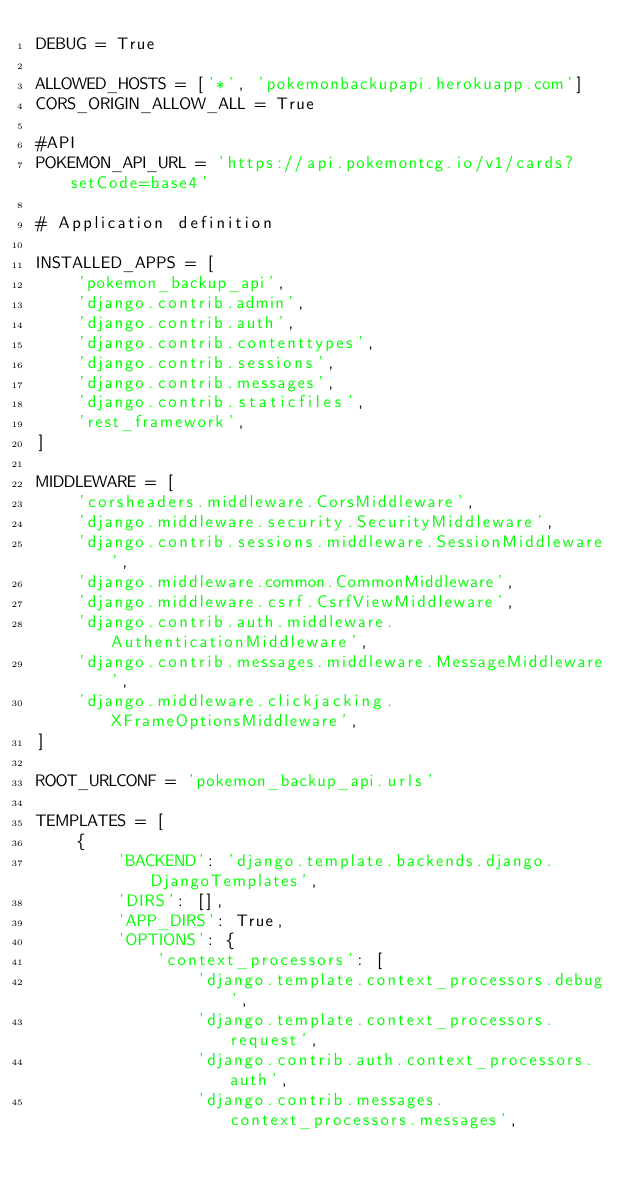Convert code to text. <code><loc_0><loc_0><loc_500><loc_500><_Python_>DEBUG = True

ALLOWED_HOSTS = ['*', 'pokemonbackupapi.herokuapp.com']
CORS_ORIGIN_ALLOW_ALL = True

#API
POKEMON_API_URL = 'https://api.pokemontcg.io/v1/cards?setCode=base4'

# Application definition

INSTALLED_APPS = [
    'pokemon_backup_api',
    'django.contrib.admin',
    'django.contrib.auth',
    'django.contrib.contenttypes',
    'django.contrib.sessions',
    'django.contrib.messages',
    'django.contrib.staticfiles',
    'rest_framework',
]

MIDDLEWARE = [
    'corsheaders.middleware.CorsMiddleware',
    'django.middleware.security.SecurityMiddleware',
    'django.contrib.sessions.middleware.SessionMiddleware',
    'django.middleware.common.CommonMiddleware',
    'django.middleware.csrf.CsrfViewMiddleware',
    'django.contrib.auth.middleware.AuthenticationMiddleware',
    'django.contrib.messages.middleware.MessageMiddleware',
    'django.middleware.clickjacking.XFrameOptionsMiddleware',
]

ROOT_URLCONF = 'pokemon_backup_api.urls'

TEMPLATES = [
    {
        'BACKEND': 'django.template.backends.django.DjangoTemplates',
        'DIRS': [],
        'APP_DIRS': True,
        'OPTIONS': {
            'context_processors': [
                'django.template.context_processors.debug',
                'django.template.context_processors.request',
                'django.contrib.auth.context_processors.auth',
                'django.contrib.messages.context_processors.messages',</code> 